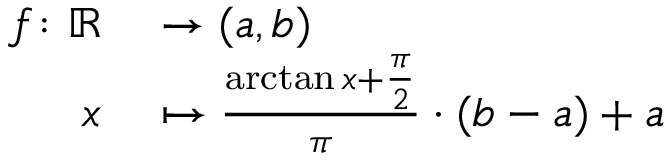<formula> <loc_0><loc_0><loc_500><loc_500>\begin{array} { r l } { f \colon \mathbb { R } } & \to ( a , b ) } \\ { x } & \mapsto { \frac { \arctan x + { \frac { \pi } { 2 } } } { \pi } } \cdot ( b - a ) + a } \end{array}</formula> 